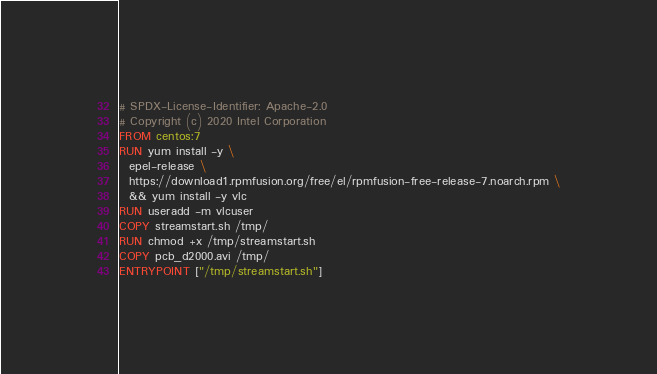Convert code to text. <code><loc_0><loc_0><loc_500><loc_500><_Dockerfile_># SPDX-License-Identifier: Apache-2.0
# Copyright (c) 2020 Intel Corporation
FROM centos:7
RUN yum install -y \
  epel-release \
  https://download1.rpmfusion.org/free/el/rpmfusion-free-release-7.noarch.rpm \
  && yum install -y vlc
RUN useradd -m vlcuser
COPY streamstart.sh /tmp/
RUN chmod +x /tmp/streamstart.sh
COPY pcb_d2000.avi /tmp/
ENTRYPOINT ["/tmp/streamstart.sh"]
</code> 